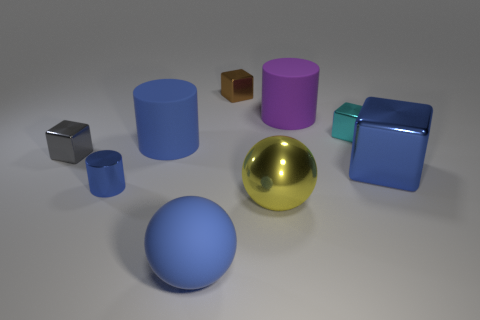Subtract all blocks. How many objects are left? 5 Subtract 0 purple cubes. How many objects are left? 9 Subtract all small gray cubes. Subtract all tiny blue shiny cylinders. How many objects are left? 7 Add 1 purple rubber things. How many purple rubber things are left? 2 Add 7 brown metal spheres. How many brown metal spheres exist? 7 